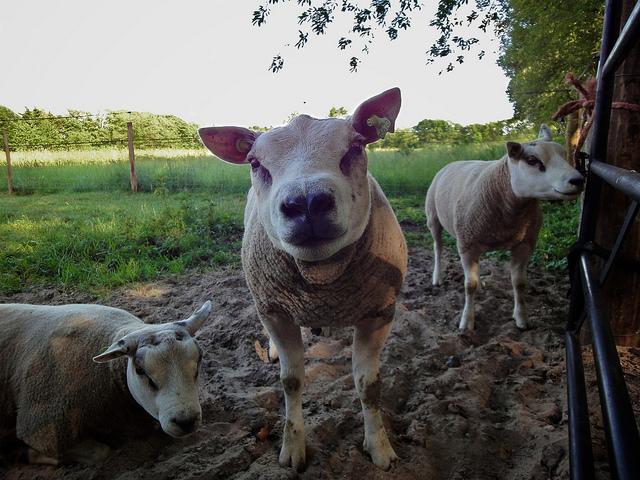Is this in nature or fenced in?
Be succinct. Fenced in. Are they adult animals?
Quick response, please. No. Is that a cow?
Concise answer only. No. What item is made from this animal's fur?
Keep it brief. Wool. How many animals are there?
Concise answer only. 3. 